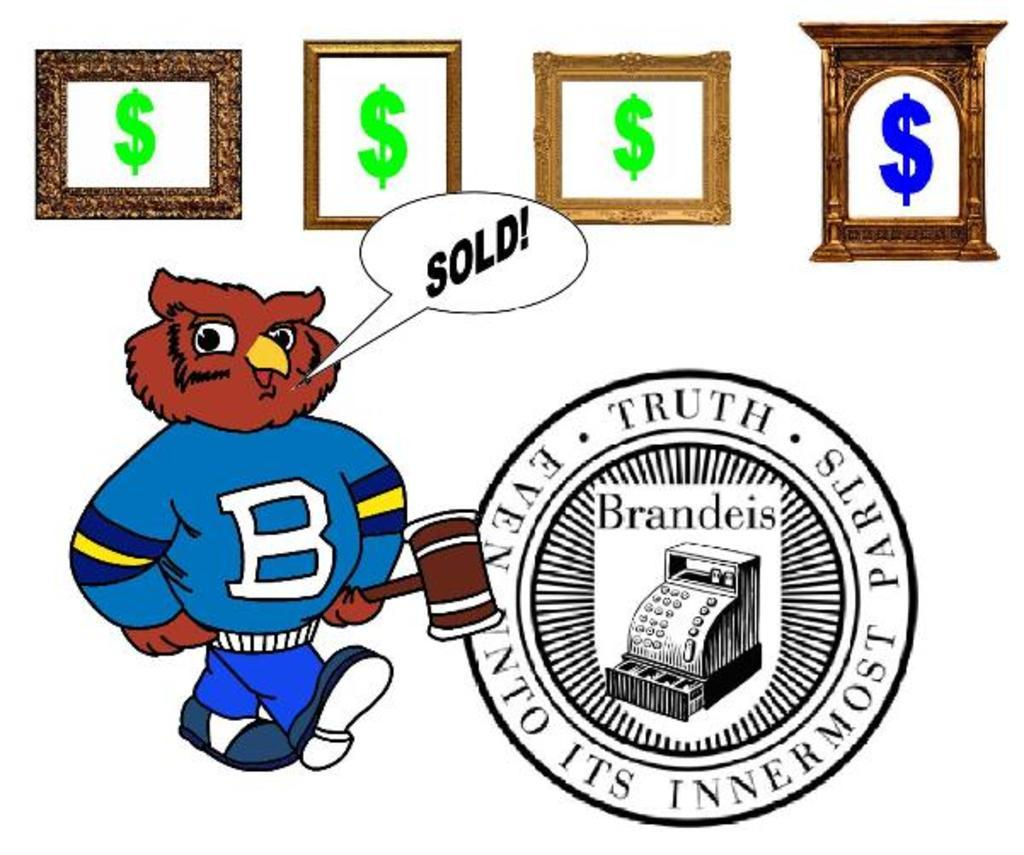What type of visual is depicted in the image? The image appears to be a poster. What can be seen on the poster? There is a logo on the poster and a person wearing a blue dress. What is the person holding in the poster? The person is holding a hammer in the poster. What symbol is present on the frame of the poster? There is a dollar sign on the frame of the poster. What type of juice is being served in the crib in the image? There is no crib or juice present in the image; it features a poster with a person holding a hammer. 